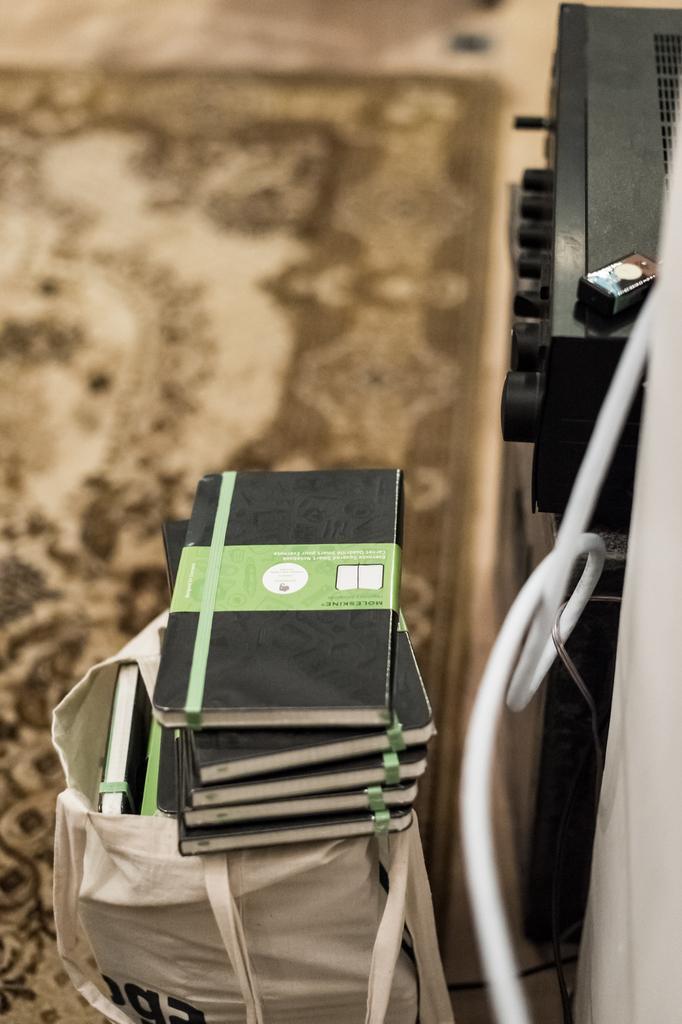Please provide a concise description of this image. This image consists of books in black color kept on a white bag. At the bottom, there is a floor mat. On the right, there are electronic devices along with a wire in white color. 